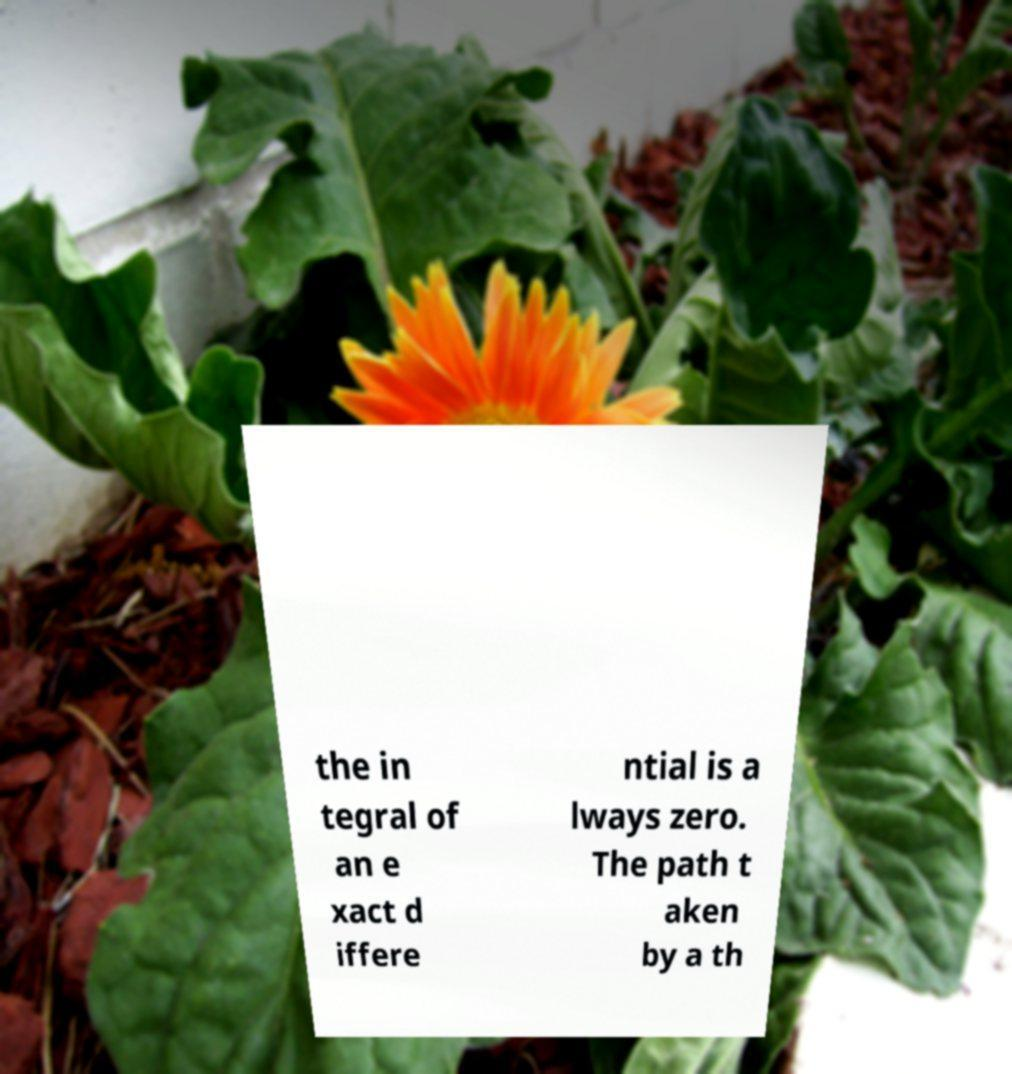For documentation purposes, I need the text within this image transcribed. Could you provide that? the in tegral of an e xact d iffere ntial is a lways zero. The path t aken by a th 